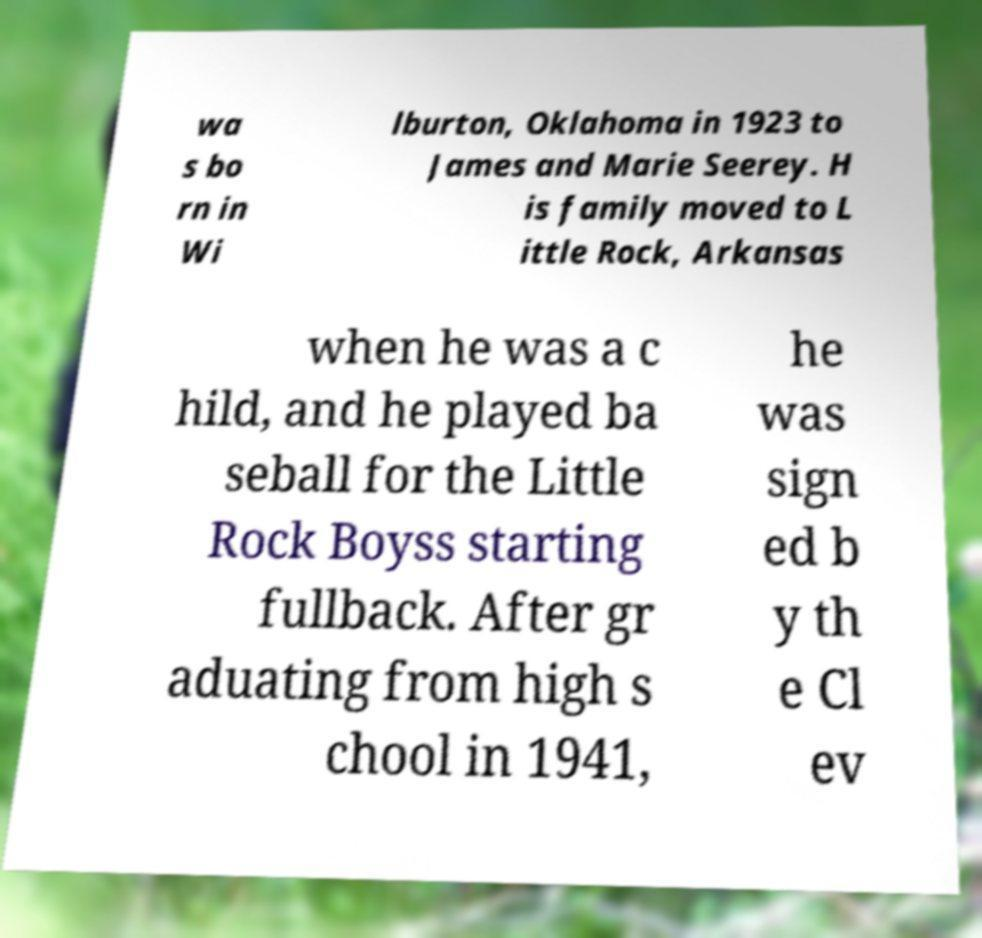I need the written content from this picture converted into text. Can you do that? wa s bo rn in Wi lburton, Oklahoma in 1923 to James and Marie Seerey. H is family moved to L ittle Rock, Arkansas when he was a c hild, and he played ba seball for the Little Rock Boyss starting fullback. After gr aduating from high s chool in 1941, he was sign ed b y th e Cl ev 